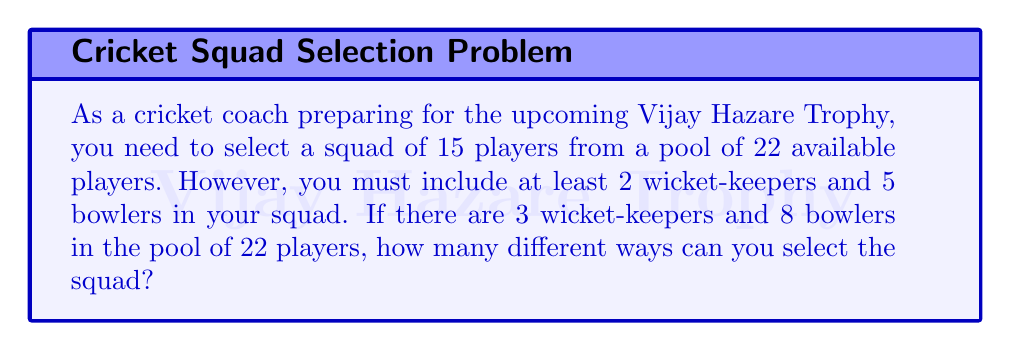Show me your answer to this math problem. Let's approach this step-by-step using the principles of set theory and combinatorics:

1) First, we need to select the wicket-keepers:
   - We must choose at least 2 out of 3 wicket-keepers.
   - This can be done in two ways:
     a) Choose 2 out of 3: $\binom{3}{2} = 3$ ways
     b) Choose 3 out of 3: $\binom{3}{3} = 1$ way
   - Total ways to choose wicket-keepers: $3 + 1 = 4$ ways

2) Next, we need to select the bowlers:
   - We must choose at least 5 out of 8 bowlers.
   - This can be done in four ways:
     a) Choose 5 out of 8: $\binom{8}{5}$ ways
     b) Choose 6 out of 8: $\binom{8}{6}$ ways
     c) Choose 7 out of 8: $\binom{8}{7}$ ways
     d) Choose 8 out of 8: $\binom{8}{8}$ way
   - Total ways to choose bowlers: $\binom{8}{5} + \binom{8}{6} + \binom{8}{7} + \binom{8}{8}$

3) For the remaining slots:
   - If we chose 2 wicket-keepers and 5 bowlers, we need to fill 8 more slots
   - If we chose 2 wicket-keepers and 6 bowlers, we need to fill 7 more slots
   - If we chose 2 wicket-keepers and 7 bowlers, we need to fill 6 more slots
   - If we chose 2 wicket-keepers and 8 bowlers, we need to fill 5 more slots
   - If we chose 3 wicket-keepers and 5 bowlers, we need to fill 7 more slots
   - If we chose 3 wicket-keepers and 6 bowlers, we need to fill 6 more slots
   - If we chose 3 wicket-keepers and 7 bowlers, we need to fill 5 more slots
   - If we chose 3 wicket-keepers and 8 bowlers, we need to fill 4 more slots

4) The remaining players to choose from are 22 - 3 - 8 = 11 players

5) Using the multiplication principle, the total number of ways to select the squad is:

   $$\left(\binom{3}{2}\left(\binom{8}{5}\binom{11}{8} + \binom{8}{6}\binom{11}{7} + \binom{8}{7}\binom{11}{6} + \binom{8}{8}\binom{11}{5}\right)\right) +$$
   $$\left(\binom{3}{3}\left(\binom{8}{5}\binom{11}{7} + \binom{8}{6}\binom{11}{6} + \binom{8}{7}\binom{11}{5} + \binom{8}{8}\binom{11}{4}\right)\right)$$

6) Calculating this expression gives us the final answer.
Answer: The number of different ways to select the squad is 1,891,890. 